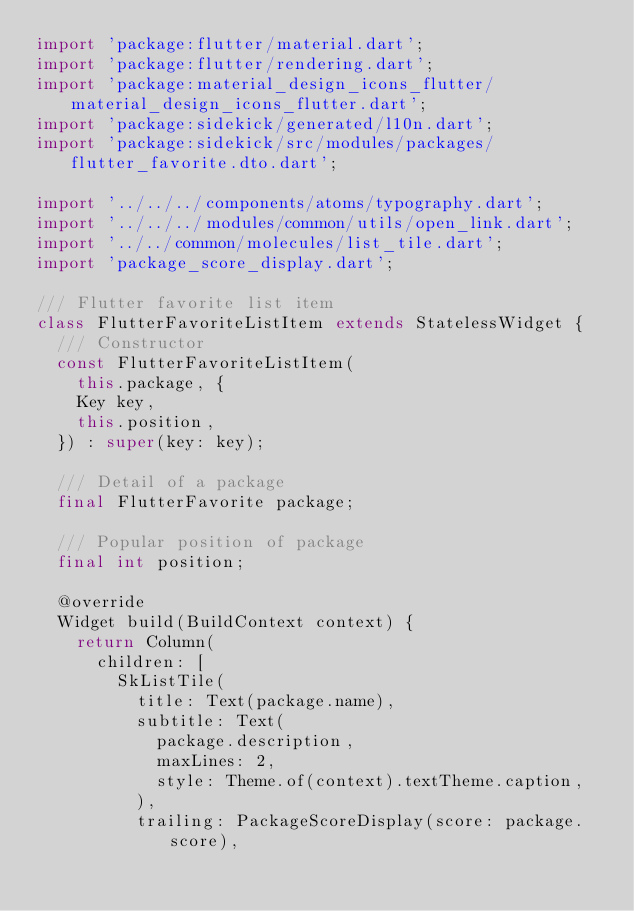<code> <loc_0><loc_0><loc_500><loc_500><_Dart_>import 'package:flutter/material.dart';
import 'package:flutter/rendering.dart';
import 'package:material_design_icons_flutter/material_design_icons_flutter.dart';
import 'package:sidekick/generated/l10n.dart';
import 'package:sidekick/src/modules/packages/flutter_favorite.dto.dart';

import '../../../components/atoms/typography.dart';
import '../../../modules/common/utils/open_link.dart';
import '../../common/molecules/list_tile.dart';
import 'package_score_display.dart';

/// Flutter favorite list item
class FlutterFavoriteListItem extends StatelessWidget {
  /// Constructor
  const FlutterFavoriteListItem(
    this.package, {
    Key key,
    this.position,
  }) : super(key: key);

  /// Detail of a package
  final FlutterFavorite package;

  /// Popular position of package
  final int position;

  @override
  Widget build(BuildContext context) {
    return Column(
      children: [
        SkListTile(
          title: Text(package.name),
          subtitle: Text(
            package.description,
            maxLines: 2,
            style: Theme.of(context).textTheme.caption,
          ),
          trailing: PackageScoreDisplay(score: package.score),</code> 